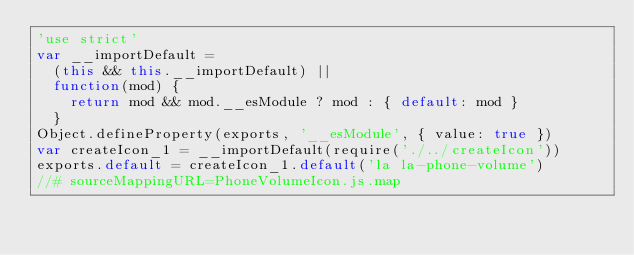<code> <loc_0><loc_0><loc_500><loc_500><_JavaScript_>'use strict'
var __importDefault =
  (this && this.__importDefault) ||
  function(mod) {
    return mod && mod.__esModule ? mod : { default: mod }
  }
Object.defineProperty(exports, '__esModule', { value: true })
var createIcon_1 = __importDefault(require('./../createIcon'))
exports.default = createIcon_1.default('la la-phone-volume')
//# sourceMappingURL=PhoneVolumeIcon.js.map
</code> 